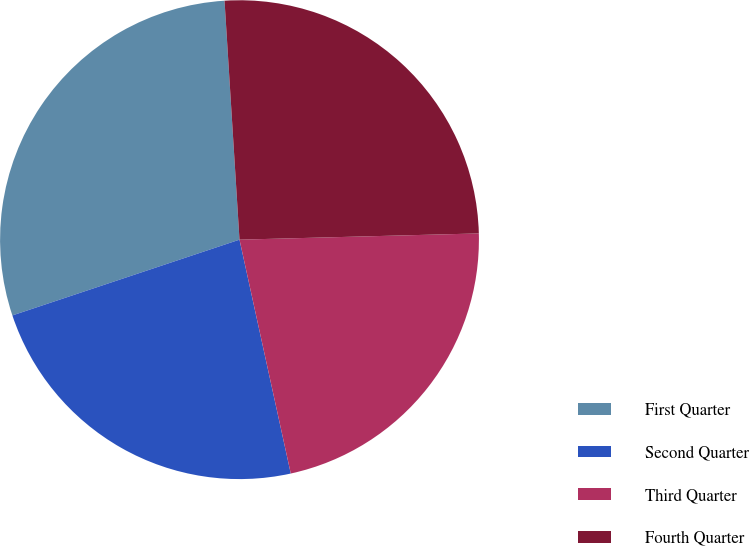<chart> <loc_0><loc_0><loc_500><loc_500><pie_chart><fcel>First Quarter<fcel>Second Quarter<fcel>Third Quarter<fcel>Fourth Quarter<nl><fcel>29.13%<fcel>23.31%<fcel>21.98%<fcel>25.58%<nl></chart> 